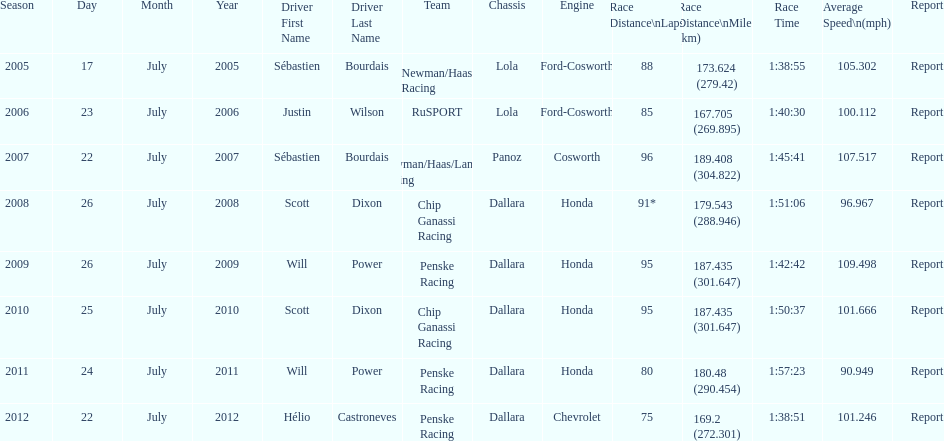Was the average speed in the year 2011 of the indycar series above or below the average speed of the year before? Below. 